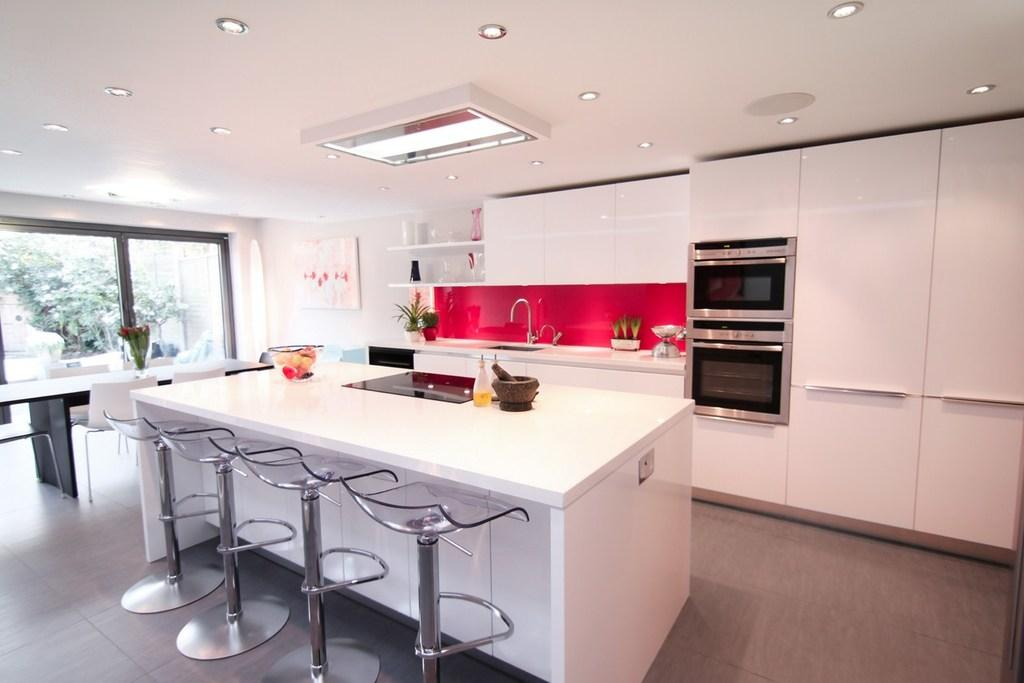What type of furniture is in the image? There is a kitchen table in the image. Are there any chairs near the table? Yes, there are chairs near the table. What can be found on the countertop in the image? There is a sink and a tap on the countertop in the image. What appliance is visible in the background of the image? There is an oven in the background of the image. What is visible through the window in the background? Trees are visible through the window. What type of ink is being used to write on the love letters in the image? There are no love letters or ink present in the image. Can you tell me how many animals are visible in the zoo through the window in the image? There is no zoo visible through the window in the image; only trees are visible. 